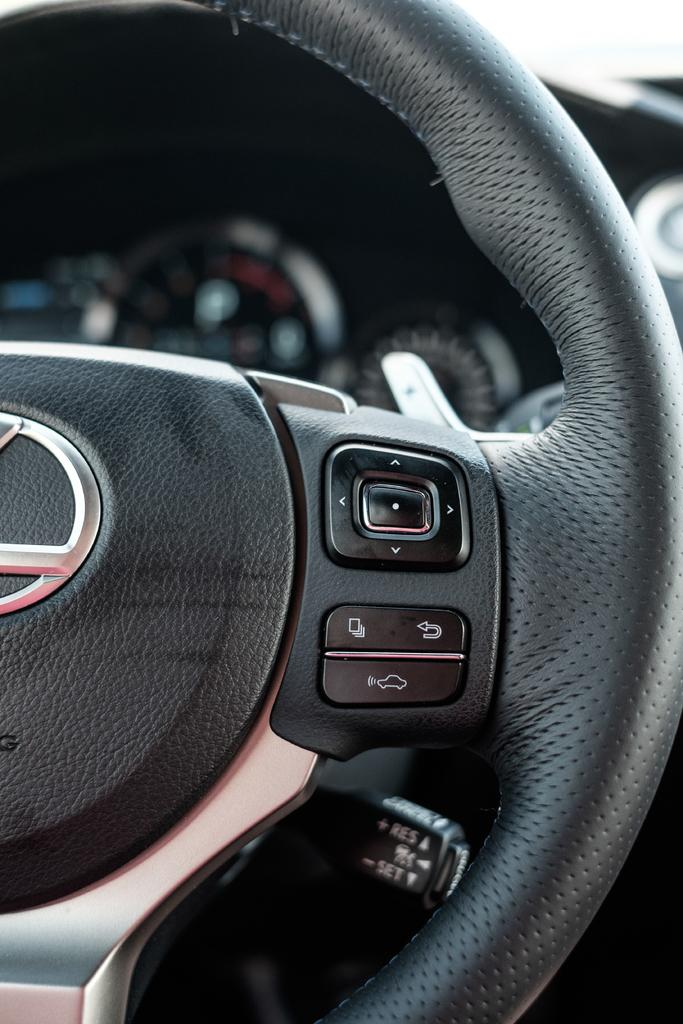What is the main object in the image? There is a steering wheel with buttons in the image. Can you describe the background of the image? The background of the image is blurry. What else can be seen in the background of the image? There are meters visible in the background of the image. What type of joke is being told by the caption in the image? There is no caption present in the image, so it is not possible to determine if a joke is being told. 